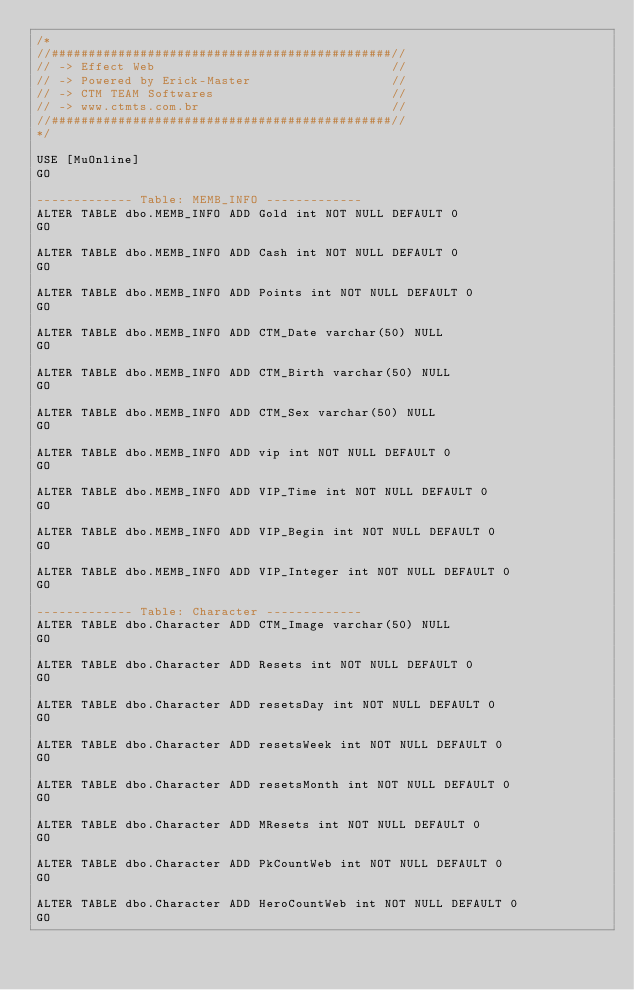Convert code to text. <code><loc_0><loc_0><loc_500><loc_500><_SQL_>/*
//##############################################//
// -> Effect Web                                //
// -> Powered by Erick-Master                   //
// -> CTM TEAM Softwares                        //
// -> www.ctmts.com.br                          //
//##############################################//
*/

USE [MuOnline]
GO

------------- Table: MEMB_INFO -------------
ALTER TABLE dbo.MEMB_INFO ADD Gold int NOT NULL DEFAULT 0 
GO

ALTER TABLE dbo.MEMB_INFO ADD Cash int NOT NULL DEFAULT 0 
GO

ALTER TABLE dbo.MEMB_INFO ADD Points int NOT NULL DEFAULT 0 
GO

ALTER TABLE dbo.MEMB_INFO ADD CTM_Date varchar(50) NULL
GO

ALTER TABLE dbo.MEMB_INFO ADD CTM_Birth varchar(50) NULL
GO

ALTER TABLE dbo.MEMB_INFO ADD CTM_Sex varchar(50) NULL
GO

ALTER TABLE dbo.MEMB_INFO ADD vip int NOT NULL DEFAULT 0 
GO

ALTER TABLE dbo.MEMB_INFO ADD VIP_Time int NOT NULL DEFAULT 0 
GO

ALTER TABLE dbo.MEMB_INFO ADD VIP_Begin int NOT NULL DEFAULT 0 
GO

ALTER TABLE dbo.MEMB_INFO ADD VIP_Integer int NOT NULL DEFAULT 0 
GO

------------- Table: Character -------------
ALTER TABLE dbo.Character ADD CTM_Image varchar(50) NULL
GO

ALTER TABLE dbo.Character ADD Resets int NOT NULL DEFAULT 0 
GO

ALTER TABLE dbo.Character ADD resetsDay int NOT NULL DEFAULT 0 
GO

ALTER TABLE dbo.Character ADD resetsWeek int NOT NULL DEFAULT 0 
GO

ALTER TABLE dbo.Character ADD resetsMonth int NOT NULL DEFAULT 0 
GO

ALTER TABLE dbo.Character ADD MResets int NOT NULL DEFAULT 0 
GO

ALTER TABLE dbo.Character ADD PkCountWeb int NOT NULL DEFAULT 0 
GO

ALTER TABLE dbo.Character ADD HeroCountWeb int NOT NULL DEFAULT 0 
GO</code> 